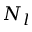<formula> <loc_0><loc_0><loc_500><loc_500>N _ { l }</formula> 